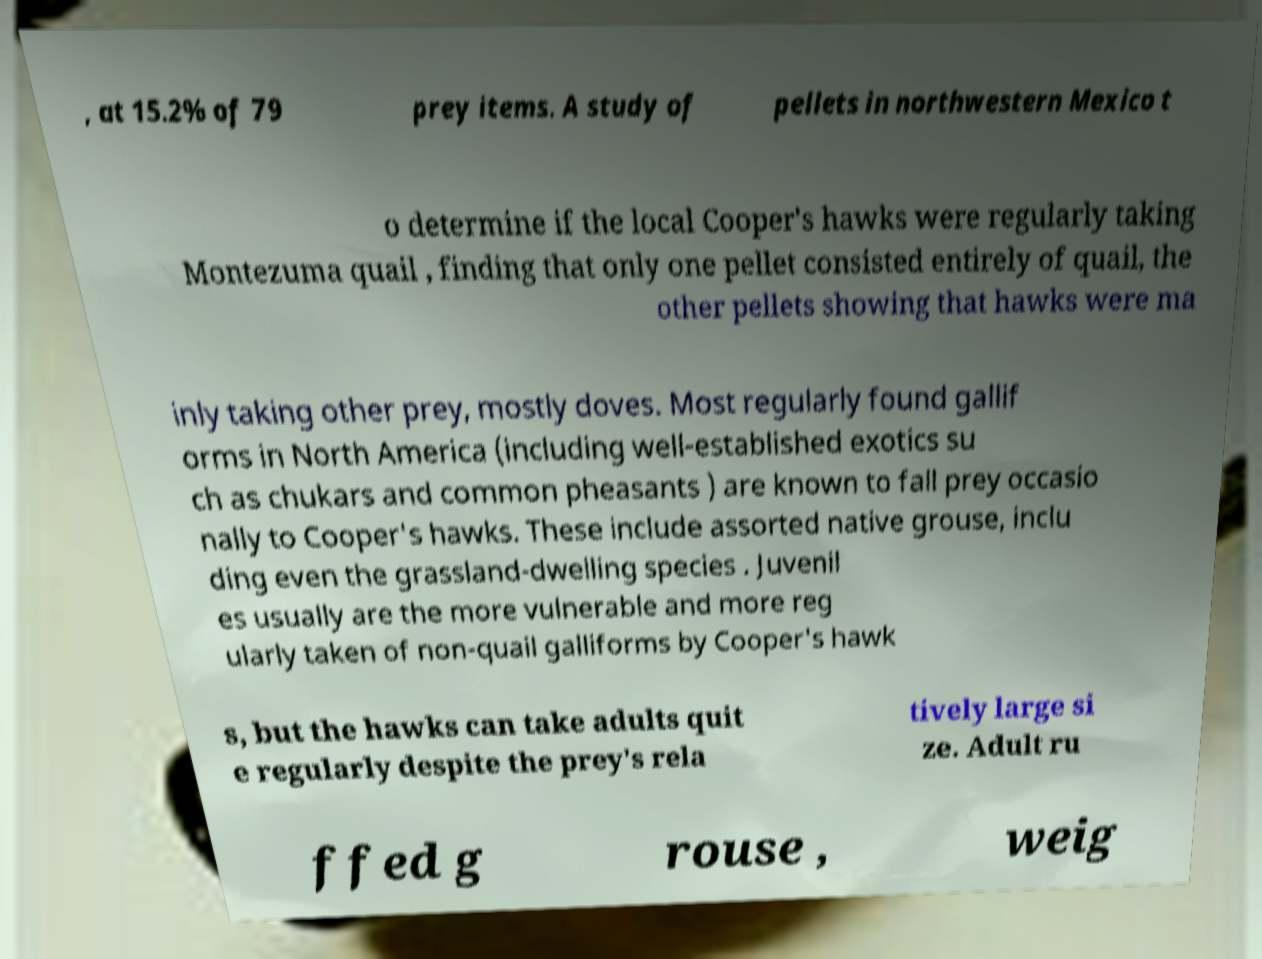What messages or text are displayed in this image? I need them in a readable, typed format. , at 15.2% of 79 prey items. A study of pellets in northwestern Mexico t o determine if the local Cooper's hawks were regularly taking Montezuma quail , finding that only one pellet consisted entirely of quail, the other pellets showing that hawks were ma inly taking other prey, mostly doves. Most regularly found gallif orms in North America (including well-established exotics su ch as chukars and common pheasants ) are known to fall prey occasio nally to Cooper's hawks. These include assorted native grouse, inclu ding even the grassland-dwelling species . Juvenil es usually are the more vulnerable and more reg ularly taken of non-quail galliforms by Cooper's hawk s, but the hawks can take adults quit e regularly despite the prey's rela tively large si ze. Adult ru ffed g rouse , weig 